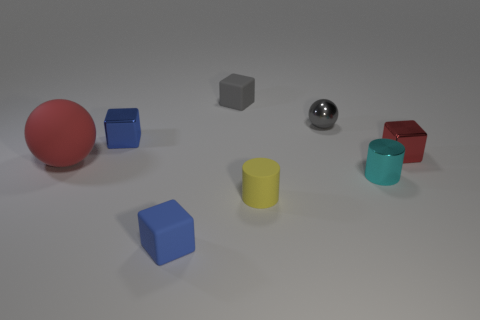Subtract 1 cubes. How many cubes are left? 3 Subtract all yellow cubes. Subtract all gray balls. How many cubes are left? 4 Add 2 cyan shiny cylinders. How many objects exist? 10 Subtract all cylinders. How many objects are left? 6 Subtract 1 gray cubes. How many objects are left? 7 Subtract all brown shiny cylinders. Subtract all red shiny blocks. How many objects are left? 7 Add 7 gray things. How many gray things are left? 9 Add 2 big green cubes. How many big green cubes exist? 2 